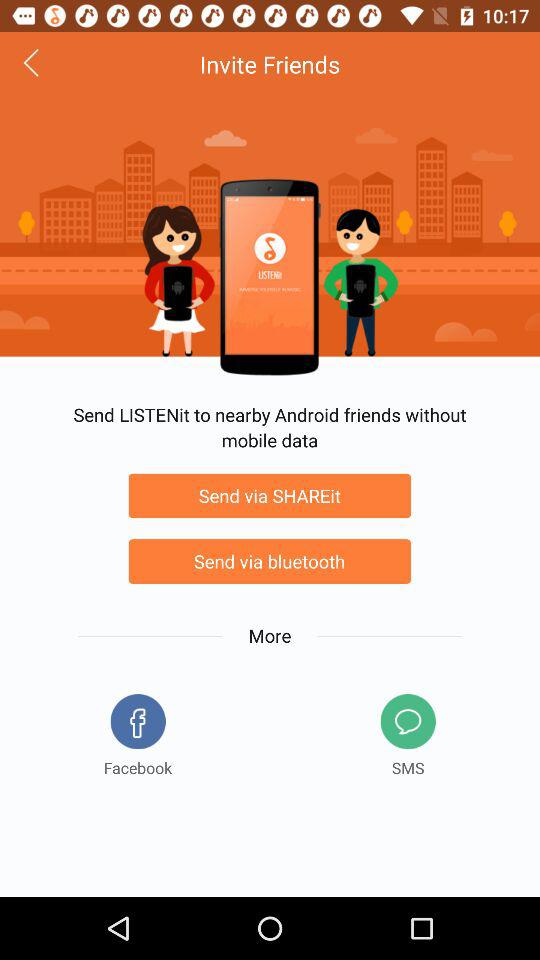What are the names of other applications that can be used to share "LISTENit"? The names of other applications that can be used to share "LISTENit" are "Facebook" and "SMS". 